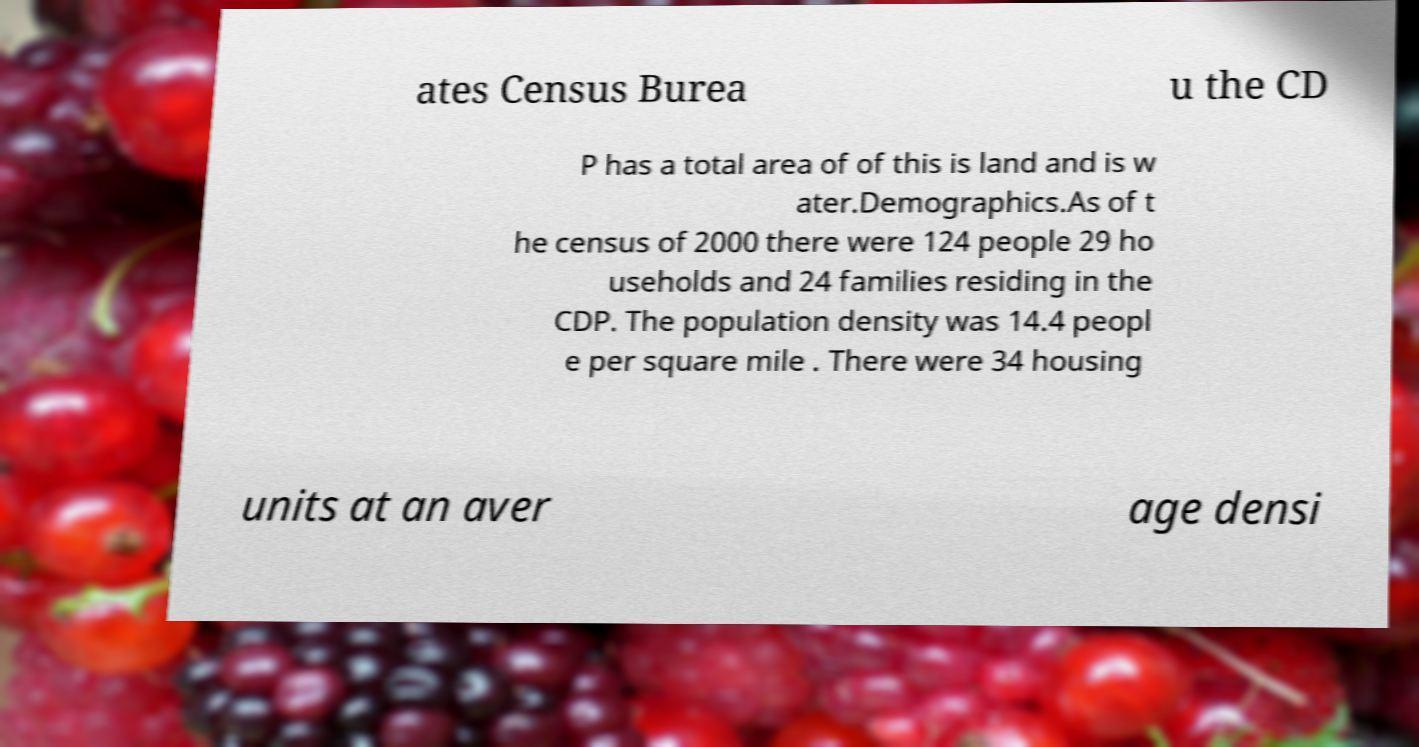I need the written content from this picture converted into text. Can you do that? ates Census Burea u the CD P has a total area of of this is land and is w ater.Demographics.As of t he census of 2000 there were 124 people 29 ho useholds and 24 families residing in the CDP. The population density was 14.4 peopl e per square mile . There were 34 housing units at an aver age densi 